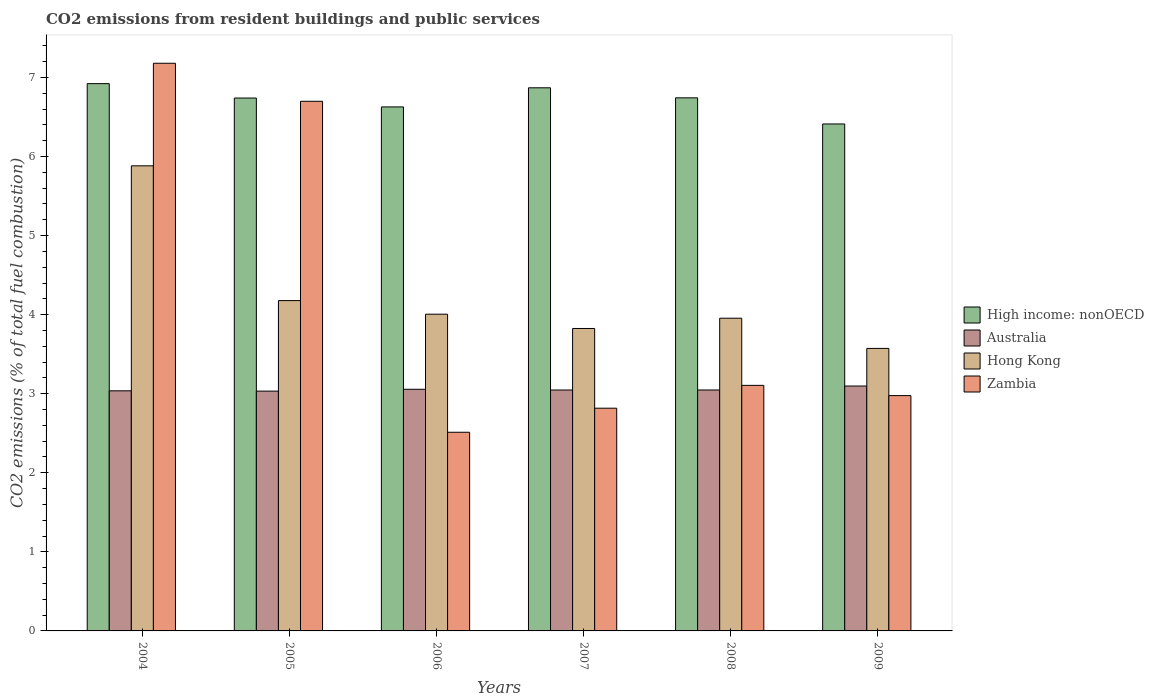How many bars are there on the 5th tick from the left?
Your answer should be compact. 4. How many bars are there on the 4th tick from the right?
Your answer should be very brief. 4. In how many cases, is the number of bars for a given year not equal to the number of legend labels?
Offer a terse response. 0. What is the total CO2 emitted in Hong Kong in 2009?
Give a very brief answer. 3.57. Across all years, what is the maximum total CO2 emitted in High income: nonOECD?
Give a very brief answer. 6.92. Across all years, what is the minimum total CO2 emitted in Hong Kong?
Offer a terse response. 3.57. What is the total total CO2 emitted in Hong Kong in the graph?
Keep it short and to the point. 25.42. What is the difference between the total CO2 emitted in Zambia in 2004 and that in 2008?
Your answer should be compact. 4.07. What is the difference between the total CO2 emitted in Australia in 2005 and the total CO2 emitted in High income: nonOECD in 2006?
Provide a short and direct response. -3.59. What is the average total CO2 emitted in High income: nonOECD per year?
Make the answer very short. 6.72. In the year 2006, what is the difference between the total CO2 emitted in Zambia and total CO2 emitted in Hong Kong?
Give a very brief answer. -1.49. What is the ratio of the total CO2 emitted in Zambia in 2007 to that in 2008?
Your answer should be compact. 0.91. Is the total CO2 emitted in High income: nonOECD in 2008 less than that in 2009?
Ensure brevity in your answer.  No. What is the difference between the highest and the second highest total CO2 emitted in Hong Kong?
Provide a short and direct response. 1.7. What is the difference between the highest and the lowest total CO2 emitted in High income: nonOECD?
Your answer should be very brief. 0.51. Is it the case that in every year, the sum of the total CO2 emitted in Zambia and total CO2 emitted in Hong Kong is greater than the sum of total CO2 emitted in High income: nonOECD and total CO2 emitted in Australia?
Offer a terse response. No. What does the 3rd bar from the left in 2005 represents?
Provide a succinct answer. Hong Kong. What does the 1st bar from the right in 2008 represents?
Provide a succinct answer. Zambia. How many bars are there?
Keep it short and to the point. 24. What is the difference between two consecutive major ticks on the Y-axis?
Your answer should be compact. 1. Are the values on the major ticks of Y-axis written in scientific E-notation?
Offer a terse response. No. Does the graph contain any zero values?
Keep it short and to the point. No. Where does the legend appear in the graph?
Offer a terse response. Center right. How many legend labels are there?
Your response must be concise. 4. How are the legend labels stacked?
Your response must be concise. Vertical. What is the title of the graph?
Provide a succinct answer. CO2 emissions from resident buildings and public services. What is the label or title of the Y-axis?
Provide a succinct answer. CO2 emissions (% of total fuel combustion). What is the CO2 emissions (% of total fuel combustion) in High income: nonOECD in 2004?
Give a very brief answer. 6.92. What is the CO2 emissions (% of total fuel combustion) in Australia in 2004?
Your answer should be very brief. 3.04. What is the CO2 emissions (% of total fuel combustion) of Hong Kong in 2004?
Your answer should be compact. 5.88. What is the CO2 emissions (% of total fuel combustion) of Zambia in 2004?
Your response must be concise. 7.18. What is the CO2 emissions (% of total fuel combustion) of High income: nonOECD in 2005?
Provide a short and direct response. 6.74. What is the CO2 emissions (% of total fuel combustion) of Australia in 2005?
Make the answer very short. 3.03. What is the CO2 emissions (% of total fuel combustion) in Hong Kong in 2005?
Your answer should be very brief. 4.18. What is the CO2 emissions (% of total fuel combustion) in Zambia in 2005?
Make the answer very short. 6.7. What is the CO2 emissions (% of total fuel combustion) of High income: nonOECD in 2006?
Give a very brief answer. 6.63. What is the CO2 emissions (% of total fuel combustion) in Australia in 2006?
Offer a very short reply. 3.06. What is the CO2 emissions (% of total fuel combustion) of Hong Kong in 2006?
Make the answer very short. 4.01. What is the CO2 emissions (% of total fuel combustion) of Zambia in 2006?
Offer a very short reply. 2.51. What is the CO2 emissions (% of total fuel combustion) of High income: nonOECD in 2007?
Provide a succinct answer. 6.87. What is the CO2 emissions (% of total fuel combustion) in Australia in 2007?
Your answer should be compact. 3.05. What is the CO2 emissions (% of total fuel combustion) in Hong Kong in 2007?
Your answer should be very brief. 3.83. What is the CO2 emissions (% of total fuel combustion) of Zambia in 2007?
Give a very brief answer. 2.82. What is the CO2 emissions (% of total fuel combustion) of High income: nonOECD in 2008?
Your answer should be compact. 6.74. What is the CO2 emissions (% of total fuel combustion) of Australia in 2008?
Your answer should be very brief. 3.05. What is the CO2 emissions (% of total fuel combustion) of Hong Kong in 2008?
Give a very brief answer. 3.96. What is the CO2 emissions (% of total fuel combustion) in Zambia in 2008?
Ensure brevity in your answer.  3.11. What is the CO2 emissions (% of total fuel combustion) of High income: nonOECD in 2009?
Make the answer very short. 6.41. What is the CO2 emissions (% of total fuel combustion) of Australia in 2009?
Keep it short and to the point. 3.1. What is the CO2 emissions (% of total fuel combustion) of Hong Kong in 2009?
Your response must be concise. 3.57. What is the CO2 emissions (% of total fuel combustion) of Zambia in 2009?
Keep it short and to the point. 2.98. Across all years, what is the maximum CO2 emissions (% of total fuel combustion) in High income: nonOECD?
Ensure brevity in your answer.  6.92. Across all years, what is the maximum CO2 emissions (% of total fuel combustion) in Australia?
Your response must be concise. 3.1. Across all years, what is the maximum CO2 emissions (% of total fuel combustion) in Hong Kong?
Keep it short and to the point. 5.88. Across all years, what is the maximum CO2 emissions (% of total fuel combustion) of Zambia?
Your answer should be compact. 7.18. Across all years, what is the minimum CO2 emissions (% of total fuel combustion) in High income: nonOECD?
Make the answer very short. 6.41. Across all years, what is the minimum CO2 emissions (% of total fuel combustion) in Australia?
Your answer should be very brief. 3.03. Across all years, what is the minimum CO2 emissions (% of total fuel combustion) of Hong Kong?
Ensure brevity in your answer.  3.57. Across all years, what is the minimum CO2 emissions (% of total fuel combustion) in Zambia?
Give a very brief answer. 2.51. What is the total CO2 emissions (% of total fuel combustion) of High income: nonOECD in the graph?
Give a very brief answer. 40.31. What is the total CO2 emissions (% of total fuel combustion) in Australia in the graph?
Keep it short and to the point. 18.32. What is the total CO2 emissions (% of total fuel combustion) in Hong Kong in the graph?
Offer a very short reply. 25.42. What is the total CO2 emissions (% of total fuel combustion) of Zambia in the graph?
Offer a terse response. 25.29. What is the difference between the CO2 emissions (% of total fuel combustion) of High income: nonOECD in 2004 and that in 2005?
Offer a very short reply. 0.18. What is the difference between the CO2 emissions (% of total fuel combustion) in Australia in 2004 and that in 2005?
Offer a terse response. 0. What is the difference between the CO2 emissions (% of total fuel combustion) of Hong Kong in 2004 and that in 2005?
Your answer should be compact. 1.7. What is the difference between the CO2 emissions (% of total fuel combustion) in Zambia in 2004 and that in 2005?
Ensure brevity in your answer.  0.48. What is the difference between the CO2 emissions (% of total fuel combustion) of High income: nonOECD in 2004 and that in 2006?
Keep it short and to the point. 0.29. What is the difference between the CO2 emissions (% of total fuel combustion) of Australia in 2004 and that in 2006?
Offer a terse response. -0.02. What is the difference between the CO2 emissions (% of total fuel combustion) in Hong Kong in 2004 and that in 2006?
Give a very brief answer. 1.88. What is the difference between the CO2 emissions (% of total fuel combustion) of Zambia in 2004 and that in 2006?
Your answer should be compact. 4.67. What is the difference between the CO2 emissions (% of total fuel combustion) of High income: nonOECD in 2004 and that in 2007?
Offer a very short reply. 0.05. What is the difference between the CO2 emissions (% of total fuel combustion) in Australia in 2004 and that in 2007?
Your answer should be very brief. -0.01. What is the difference between the CO2 emissions (% of total fuel combustion) in Hong Kong in 2004 and that in 2007?
Offer a very short reply. 2.06. What is the difference between the CO2 emissions (% of total fuel combustion) of Zambia in 2004 and that in 2007?
Provide a short and direct response. 4.36. What is the difference between the CO2 emissions (% of total fuel combustion) in High income: nonOECD in 2004 and that in 2008?
Keep it short and to the point. 0.18. What is the difference between the CO2 emissions (% of total fuel combustion) in Australia in 2004 and that in 2008?
Your answer should be very brief. -0.01. What is the difference between the CO2 emissions (% of total fuel combustion) in Hong Kong in 2004 and that in 2008?
Your answer should be compact. 1.93. What is the difference between the CO2 emissions (% of total fuel combustion) in Zambia in 2004 and that in 2008?
Keep it short and to the point. 4.07. What is the difference between the CO2 emissions (% of total fuel combustion) of High income: nonOECD in 2004 and that in 2009?
Ensure brevity in your answer.  0.51. What is the difference between the CO2 emissions (% of total fuel combustion) in Australia in 2004 and that in 2009?
Provide a succinct answer. -0.06. What is the difference between the CO2 emissions (% of total fuel combustion) of Hong Kong in 2004 and that in 2009?
Make the answer very short. 2.31. What is the difference between the CO2 emissions (% of total fuel combustion) in Zambia in 2004 and that in 2009?
Provide a short and direct response. 4.2. What is the difference between the CO2 emissions (% of total fuel combustion) in High income: nonOECD in 2005 and that in 2006?
Ensure brevity in your answer.  0.11. What is the difference between the CO2 emissions (% of total fuel combustion) in Australia in 2005 and that in 2006?
Offer a terse response. -0.02. What is the difference between the CO2 emissions (% of total fuel combustion) of Hong Kong in 2005 and that in 2006?
Keep it short and to the point. 0.17. What is the difference between the CO2 emissions (% of total fuel combustion) of Zambia in 2005 and that in 2006?
Your response must be concise. 4.19. What is the difference between the CO2 emissions (% of total fuel combustion) in High income: nonOECD in 2005 and that in 2007?
Keep it short and to the point. -0.13. What is the difference between the CO2 emissions (% of total fuel combustion) of Australia in 2005 and that in 2007?
Ensure brevity in your answer.  -0.01. What is the difference between the CO2 emissions (% of total fuel combustion) in Hong Kong in 2005 and that in 2007?
Provide a succinct answer. 0.35. What is the difference between the CO2 emissions (% of total fuel combustion) of Zambia in 2005 and that in 2007?
Keep it short and to the point. 3.88. What is the difference between the CO2 emissions (% of total fuel combustion) of High income: nonOECD in 2005 and that in 2008?
Your response must be concise. -0. What is the difference between the CO2 emissions (% of total fuel combustion) in Australia in 2005 and that in 2008?
Offer a terse response. -0.01. What is the difference between the CO2 emissions (% of total fuel combustion) in Hong Kong in 2005 and that in 2008?
Provide a succinct answer. 0.22. What is the difference between the CO2 emissions (% of total fuel combustion) of Zambia in 2005 and that in 2008?
Offer a terse response. 3.59. What is the difference between the CO2 emissions (% of total fuel combustion) of High income: nonOECD in 2005 and that in 2009?
Give a very brief answer. 0.33. What is the difference between the CO2 emissions (% of total fuel combustion) in Australia in 2005 and that in 2009?
Your response must be concise. -0.06. What is the difference between the CO2 emissions (% of total fuel combustion) in Hong Kong in 2005 and that in 2009?
Your response must be concise. 0.6. What is the difference between the CO2 emissions (% of total fuel combustion) of Zambia in 2005 and that in 2009?
Make the answer very short. 3.72. What is the difference between the CO2 emissions (% of total fuel combustion) in High income: nonOECD in 2006 and that in 2007?
Your answer should be very brief. -0.24. What is the difference between the CO2 emissions (% of total fuel combustion) in Australia in 2006 and that in 2007?
Offer a very short reply. 0.01. What is the difference between the CO2 emissions (% of total fuel combustion) in Hong Kong in 2006 and that in 2007?
Provide a succinct answer. 0.18. What is the difference between the CO2 emissions (% of total fuel combustion) in Zambia in 2006 and that in 2007?
Provide a short and direct response. -0.3. What is the difference between the CO2 emissions (% of total fuel combustion) of High income: nonOECD in 2006 and that in 2008?
Offer a terse response. -0.11. What is the difference between the CO2 emissions (% of total fuel combustion) in Australia in 2006 and that in 2008?
Keep it short and to the point. 0.01. What is the difference between the CO2 emissions (% of total fuel combustion) of Hong Kong in 2006 and that in 2008?
Your answer should be very brief. 0.05. What is the difference between the CO2 emissions (% of total fuel combustion) in Zambia in 2006 and that in 2008?
Your answer should be very brief. -0.59. What is the difference between the CO2 emissions (% of total fuel combustion) in High income: nonOECD in 2006 and that in 2009?
Your answer should be very brief. 0.22. What is the difference between the CO2 emissions (% of total fuel combustion) of Australia in 2006 and that in 2009?
Your response must be concise. -0.04. What is the difference between the CO2 emissions (% of total fuel combustion) in Hong Kong in 2006 and that in 2009?
Provide a succinct answer. 0.43. What is the difference between the CO2 emissions (% of total fuel combustion) in Zambia in 2006 and that in 2009?
Your answer should be very brief. -0.46. What is the difference between the CO2 emissions (% of total fuel combustion) of High income: nonOECD in 2007 and that in 2008?
Provide a short and direct response. 0.13. What is the difference between the CO2 emissions (% of total fuel combustion) in Australia in 2007 and that in 2008?
Provide a succinct answer. -0. What is the difference between the CO2 emissions (% of total fuel combustion) in Hong Kong in 2007 and that in 2008?
Make the answer very short. -0.13. What is the difference between the CO2 emissions (% of total fuel combustion) of Zambia in 2007 and that in 2008?
Make the answer very short. -0.29. What is the difference between the CO2 emissions (% of total fuel combustion) in High income: nonOECD in 2007 and that in 2009?
Your answer should be very brief. 0.46. What is the difference between the CO2 emissions (% of total fuel combustion) of Australia in 2007 and that in 2009?
Ensure brevity in your answer.  -0.05. What is the difference between the CO2 emissions (% of total fuel combustion) in Hong Kong in 2007 and that in 2009?
Offer a terse response. 0.25. What is the difference between the CO2 emissions (% of total fuel combustion) of Zambia in 2007 and that in 2009?
Provide a succinct answer. -0.16. What is the difference between the CO2 emissions (% of total fuel combustion) in High income: nonOECD in 2008 and that in 2009?
Provide a short and direct response. 0.33. What is the difference between the CO2 emissions (% of total fuel combustion) of Australia in 2008 and that in 2009?
Offer a terse response. -0.05. What is the difference between the CO2 emissions (% of total fuel combustion) in Hong Kong in 2008 and that in 2009?
Provide a short and direct response. 0.38. What is the difference between the CO2 emissions (% of total fuel combustion) in Zambia in 2008 and that in 2009?
Provide a short and direct response. 0.13. What is the difference between the CO2 emissions (% of total fuel combustion) in High income: nonOECD in 2004 and the CO2 emissions (% of total fuel combustion) in Australia in 2005?
Offer a very short reply. 3.89. What is the difference between the CO2 emissions (% of total fuel combustion) of High income: nonOECD in 2004 and the CO2 emissions (% of total fuel combustion) of Hong Kong in 2005?
Offer a terse response. 2.74. What is the difference between the CO2 emissions (% of total fuel combustion) in High income: nonOECD in 2004 and the CO2 emissions (% of total fuel combustion) in Zambia in 2005?
Make the answer very short. 0.22. What is the difference between the CO2 emissions (% of total fuel combustion) in Australia in 2004 and the CO2 emissions (% of total fuel combustion) in Hong Kong in 2005?
Ensure brevity in your answer.  -1.14. What is the difference between the CO2 emissions (% of total fuel combustion) in Australia in 2004 and the CO2 emissions (% of total fuel combustion) in Zambia in 2005?
Provide a succinct answer. -3.66. What is the difference between the CO2 emissions (% of total fuel combustion) in Hong Kong in 2004 and the CO2 emissions (% of total fuel combustion) in Zambia in 2005?
Keep it short and to the point. -0.82. What is the difference between the CO2 emissions (% of total fuel combustion) in High income: nonOECD in 2004 and the CO2 emissions (% of total fuel combustion) in Australia in 2006?
Ensure brevity in your answer.  3.87. What is the difference between the CO2 emissions (% of total fuel combustion) in High income: nonOECD in 2004 and the CO2 emissions (% of total fuel combustion) in Hong Kong in 2006?
Offer a terse response. 2.92. What is the difference between the CO2 emissions (% of total fuel combustion) of High income: nonOECD in 2004 and the CO2 emissions (% of total fuel combustion) of Zambia in 2006?
Offer a very short reply. 4.41. What is the difference between the CO2 emissions (% of total fuel combustion) in Australia in 2004 and the CO2 emissions (% of total fuel combustion) in Hong Kong in 2006?
Make the answer very short. -0.97. What is the difference between the CO2 emissions (% of total fuel combustion) of Australia in 2004 and the CO2 emissions (% of total fuel combustion) of Zambia in 2006?
Offer a terse response. 0.52. What is the difference between the CO2 emissions (% of total fuel combustion) in Hong Kong in 2004 and the CO2 emissions (% of total fuel combustion) in Zambia in 2006?
Keep it short and to the point. 3.37. What is the difference between the CO2 emissions (% of total fuel combustion) of High income: nonOECD in 2004 and the CO2 emissions (% of total fuel combustion) of Australia in 2007?
Make the answer very short. 3.87. What is the difference between the CO2 emissions (% of total fuel combustion) in High income: nonOECD in 2004 and the CO2 emissions (% of total fuel combustion) in Hong Kong in 2007?
Provide a succinct answer. 3.1. What is the difference between the CO2 emissions (% of total fuel combustion) of High income: nonOECD in 2004 and the CO2 emissions (% of total fuel combustion) of Zambia in 2007?
Your response must be concise. 4.11. What is the difference between the CO2 emissions (% of total fuel combustion) of Australia in 2004 and the CO2 emissions (% of total fuel combustion) of Hong Kong in 2007?
Offer a very short reply. -0.79. What is the difference between the CO2 emissions (% of total fuel combustion) in Australia in 2004 and the CO2 emissions (% of total fuel combustion) in Zambia in 2007?
Keep it short and to the point. 0.22. What is the difference between the CO2 emissions (% of total fuel combustion) in Hong Kong in 2004 and the CO2 emissions (% of total fuel combustion) in Zambia in 2007?
Make the answer very short. 3.07. What is the difference between the CO2 emissions (% of total fuel combustion) of High income: nonOECD in 2004 and the CO2 emissions (% of total fuel combustion) of Australia in 2008?
Your answer should be very brief. 3.87. What is the difference between the CO2 emissions (% of total fuel combustion) of High income: nonOECD in 2004 and the CO2 emissions (% of total fuel combustion) of Hong Kong in 2008?
Provide a short and direct response. 2.97. What is the difference between the CO2 emissions (% of total fuel combustion) of High income: nonOECD in 2004 and the CO2 emissions (% of total fuel combustion) of Zambia in 2008?
Provide a short and direct response. 3.82. What is the difference between the CO2 emissions (% of total fuel combustion) of Australia in 2004 and the CO2 emissions (% of total fuel combustion) of Hong Kong in 2008?
Your answer should be very brief. -0.92. What is the difference between the CO2 emissions (% of total fuel combustion) in Australia in 2004 and the CO2 emissions (% of total fuel combustion) in Zambia in 2008?
Offer a very short reply. -0.07. What is the difference between the CO2 emissions (% of total fuel combustion) of Hong Kong in 2004 and the CO2 emissions (% of total fuel combustion) of Zambia in 2008?
Your answer should be compact. 2.78. What is the difference between the CO2 emissions (% of total fuel combustion) in High income: nonOECD in 2004 and the CO2 emissions (% of total fuel combustion) in Australia in 2009?
Make the answer very short. 3.82. What is the difference between the CO2 emissions (% of total fuel combustion) of High income: nonOECD in 2004 and the CO2 emissions (% of total fuel combustion) of Hong Kong in 2009?
Keep it short and to the point. 3.35. What is the difference between the CO2 emissions (% of total fuel combustion) in High income: nonOECD in 2004 and the CO2 emissions (% of total fuel combustion) in Zambia in 2009?
Give a very brief answer. 3.95. What is the difference between the CO2 emissions (% of total fuel combustion) of Australia in 2004 and the CO2 emissions (% of total fuel combustion) of Hong Kong in 2009?
Provide a succinct answer. -0.54. What is the difference between the CO2 emissions (% of total fuel combustion) in Australia in 2004 and the CO2 emissions (% of total fuel combustion) in Zambia in 2009?
Provide a short and direct response. 0.06. What is the difference between the CO2 emissions (% of total fuel combustion) in Hong Kong in 2004 and the CO2 emissions (% of total fuel combustion) in Zambia in 2009?
Your response must be concise. 2.91. What is the difference between the CO2 emissions (% of total fuel combustion) of High income: nonOECD in 2005 and the CO2 emissions (% of total fuel combustion) of Australia in 2006?
Keep it short and to the point. 3.68. What is the difference between the CO2 emissions (% of total fuel combustion) of High income: nonOECD in 2005 and the CO2 emissions (% of total fuel combustion) of Hong Kong in 2006?
Your answer should be compact. 2.73. What is the difference between the CO2 emissions (% of total fuel combustion) of High income: nonOECD in 2005 and the CO2 emissions (% of total fuel combustion) of Zambia in 2006?
Your answer should be very brief. 4.23. What is the difference between the CO2 emissions (% of total fuel combustion) in Australia in 2005 and the CO2 emissions (% of total fuel combustion) in Hong Kong in 2006?
Your response must be concise. -0.97. What is the difference between the CO2 emissions (% of total fuel combustion) in Australia in 2005 and the CO2 emissions (% of total fuel combustion) in Zambia in 2006?
Keep it short and to the point. 0.52. What is the difference between the CO2 emissions (% of total fuel combustion) in Hong Kong in 2005 and the CO2 emissions (% of total fuel combustion) in Zambia in 2006?
Your answer should be very brief. 1.67. What is the difference between the CO2 emissions (% of total fuel combustion) in High income: nonOECD in 2005 and the CO2 emissions (% of total fuel combustion) in Australia in 2007?
Offer a terse response. 3.69. What is the difference between the CO2 emissions (% of total fuel combustion) of High income: nonOECD in 2005 and the CO2 emissions (% of total fuel combustion) of Hong Kong in 2007?
Give a very brief answer. 2.91. What is the difference between the CO2 emissions (% of total fuel combustion) of High income: nonOECD in 2005 and the CO2 emissions (% of total fuel combustion) of Zambia in 2007?
Your answer should be very brief. 3.92. What is the difference between the CO2 emissions (% of total fuel combustion) of Australia in 2005 and the CO2 emissions (% of total fuel combustion) of Hong Kong in 2007?
Offer a very short reply. -0.79. What is the difference between the CO2 emissions (% of total fuel combustion) of Australia in 2005 and the CO2 emissions (% of total fuel combustion) of Zambia in 2007?
Provide a succinct answer. 0.22. What is the difference between the CO2 emissions (% of total fuel combustion) of Hong Kong in 2005 and the CO2 emissions (% of total fuel combustion) of Zambia in 2007?
Your answer should be compact. 1.36. What is the difference between the CO2 emissions (% of total fuel combustion) of High income: nonOECD in 2005 and the CO2 emissions (% of total fuel combustion) of Australia in 2008?
Provide a succinct answer. 3.69. What is the difference between the CO2 emissions (% of total fuel combustion) in High income: nonOECD in 2005 and the CO2 emissions (% of total fuel combustion) in Hong Kong in 2008?
Make the answer very short. 2.78. What is the difference between the CO2 emissions (% of total fuel combustion) in High income: nonOECD in 2005 and the CO2 emissions (% of total fuel combustion) in Zambia in 2008?
Make the answer very short. 3.63. What is the difference between the CO2 emissions (% of total fuel combustion) of Australia in 2005 and the CO2 emissions (% of total fuel combustion) of Hong Kong in 2008?
Provide a short and direct response. -0.92. What is the difference between the CO2 emissions (% of total fuel combustion) of Australia in 2005 and the CO2 emissions (% of total fuel combustion) of Zambia in 2008?
Your answer should be compact. -0.07. What is the difference between the CO2 emissions (% of total fuel combustion) of Hong Kong in 2005 and the CO2 emissions (% of total fuel combustion) of Zambia in 2008?
Provide a short and direct response. 1.07. What is the difference between the CO2 emissions (% of total fuel combustion) in High income: nonOECD in 2005 and the CO2 emissions (% of total fuel combustion) in Australia in 2009?
Offer a very short reply. 3.64. What is the difference between the CO2 emissions (% of total fuel combustion) of High income: nonOECD in 2005 and the CO2 emissions (% of total fuel combustion) of Hong Kong in 2009?
Your answer should be compact. 3.17. What is the difference between the CO2 emissions (% of total fuel combustion) of High income: nonOECD in 2005 and the CO2 emissions (% of total fuel combustion) of Zambia in 2009?
Offer a terse response. 3.76. What is the difference between the CO2 emissions (% of total fuel combustion) of Australia in 2005 and the CO2 emissions (% of total fuel combustion) of Hong Kong in 2009?
Keep it short and to the point. -0.54. What is the difference between the CO2 emissions (% of total fuel combustion) in Australia in 2005 and the CO2 emissions (% of total fuel combustion) in Zambia in 2009?
Offer a terse response. 0.06. What is the difference between the CO2 emissions (% of total fuel combustion) of Hong Kong in 2005 and the CO2 emissions (% of total fuel combustion) of Zambia in 2009?
Ensure brevity in your answer.  1.2. What is the difference between the CO2 emissions (% of total fuel combustion) of High income: nonOECD in 2006 and the CO2 emissions (% of total fuel combustion) of Australia in 2007?
Provide a short and direct response. 3.58. What is the difference between the CO2 emissions (% of total fuel combustion) of High income: nonOECD in 2006 and the CO2 emissions (% of total fuel combustion) of Hong Kong in 2007?
Offer a very short reply. 2.8. What is the difference between the CO2 emissions (% of total fuel combustion) in High income: nonOECD in 2006 and the CO2 emissions (% of total fuel combustion) in Zambia in 2007?
Your response must be concise. 3.81. What is the difference between the CO2 emissions (% of total fuel combustion) in Australia in 2006 and the CO2 emissions (% of total fuel combustion) in Hong Kong in 2007?
Keep it short and to the point. -0.77. What is the difference between the CO2 emissions (% of total fuel combustion) in Australia in 2006 and the CO2 emissions (% of total fuel combustion) in Zambia in 2007?
Keep it short and to the point. 0.24. What is the difference between the CO2 emissions (% of total fuel combustion) in Hong Kong in 2006 and the CO2 emissions (% of total fuel combustion) in Zambia in 2007?
Provide a short and direct response. 1.19. What is the difference between the CO2 emissions (% of total fuel combustion) of High income: nonOECD in 2006 and the CO2 emissions (% of total fuel combustion) of Australia in 2008?
Ensure brevity in your answer.  3.58. What is the difference between the CO2 emissions (% of total fuel combustion) of High income: nonOECD in 2006 and the CO2 emissions (% of total fuel combustion) of Hong Kong in 2008?
Your response must be concise. 2.67. What is the difference between the CO2 emissions (% of total fuel combustion) of High income: nonOECD in 2006 and the CO2 emissions (% of total fuel combustion) of Zambia in 2008?
Provide a succinct answer. 3.52. What is the difference between the CO2 emissions (% of total fuel combustion) in Australia in 2006 and the CO2 emissions (% of total fuel combustion) in Hong Kong in 2008?
Make the answer very short. -0.9. What is the difference between the CO2 emissions (% of total fuel combustion) of Australia in 2006 and the CO2 emissions (% of total fuel combustion) of Zambia in 2008?
Provide a succinct answer. -0.05. What is the difference between the CO2 emissions (% of total fuel combustion) in Hong Kong in 2006 and the CO2 emissions (% of total fuel combustion) in Zambia in 2008?
Provide a succinct answer. 0.9. What is the difference between the CO2 emissions (% of total fuel combustion) of High income: nonOECD in 2006 and the CO2 emissions (% of total fuel combustion) of Australia in 2009?
Offer a terse response. 3.53. What is the difference between the CO2 emissions (% of total fuel combustion) in High income: nonOECD in 2006 and the CO2 emissions (% of total fuel combustion) in Hong Kong in 2009?
Offer a very short reply. 3.05. What is the difference between the CO2 emissions (% of total fuel combustion) of High income: nonOECD in 2006 and the CO2 emissions (% of total fuel combustion) of Zambia in 2009?
Ensure brevity in your answer.  3.65. What is the difference between the CO2 emissions (% of total fuel combustion) in Australia in 2006 and the CO2 emissions (% of total fuel combustion) in Hong Kong in 2009?
Keep it short and to the point. -0.52. What is the difference between the CO2 emissions (% of total fuel combustion) in Australia in 2006 and the CO2 emissions (% of total fuel combustion) in Zambia in 2009?
Your response must be concise. 0.08. What is the difference between the CO2 emissions (% of total fuel combustion) of Hong Kong in 2006 and the CO2 emissions (% of total fuel combustion) of Zambia in 2009?
Offer a terse response. 1.03. What is the difference between the CO2 emissions (% of total fuel combustion) of High income: nonOECD in 2007 and the CO2 emissions (% of total fuel combustion) of Australia in 2008?
Your answer should be compact. 3.82. What is the difference between the CO2 emissions (% of total fuel combustion) in High income: nonOECD in 2007 and the CO2 emissions (% of total fuel combustion) in Hong Kong in 2008?
Offer a very short reply. 2.91. What is the difference between the CO2 emissions (% of total fuel combustion) in High income: nonOECD in 2007 and the CO2 emissions (% of total fuel combustion) in Zambia in 2008?
Make the answer very short. 3.76. What is the difference between the CO2 emissions (% of total fuel combustion) of Australia in 2007 and the CO2 emissions (% of total fuel combustion) of Hong Kong in 2008?
Provide a short and direct response. -0.91. What is the difference between the CO2 emissions (% of total fuel combustion) in Australia in 2007 and the CO2 emissions (% of total fuel combustion) in Zambia in 2008?
Provide a succinct answer. -0.06. What is the difference between the CO2 emissions (% of total fuel combustion) of Hong Kong in 2007 and the CO2 emissions (% of total fuel combustion) of Zambia in 2008?
Your answer should be very brief. 0.72. What is the difference between the CO2 emissions (% of total fuel combustion) of High income: nonOECD in 2007 and the CO2 emissions (% of total fuel combustion) of Australia in 2009?
Provide a short and direct response. 3.77. What is the difference between the CO2 emissions (% of total fuel combustion) of High income: nonOECD in 2007 and the CO2 emissions (% of total fuel combustion) of Hong Kong in 2009?
Offer a very short reply. 3.3. What is the difference between the CO2 emissions (% of total fuel combustion) in High income: nonOECD in 2007 and the CO2 emissions (% of total fuel combustion) in Zambia in 2009?
Offer a very short reply. 3.89. What is the difference between the CO2 emissions (% of total fuel combustion) in Australia in 2007 and the CO2 emissions (% of total fuel combustion) in Hong Kong in 2009?
Your response must be concise. -0.53. What is the difference between the CO2 emissions (% of total fuel combustion) in Australia in 2007 and the CO2 emissions (% of total fuel combustion) in Zambia in 2009?
Make the answer very short. 0.07. What is the difference between the CO2 emissions (% of total fuel combustion) of Hong Kong in 2007 and the CO2 emissions (% of total fuel combustion) of Zambia in 2009?
Keep it short and to the point. 0.85. What is the difference between the CO2 emissions (% of total fuel combustion) of High income: nonOECD in 2008 and the CO2 emissions (% of total fuel combustion) of Australia in 2009?
Provide a short and direct response. 3.64. What is the difference between the CO2 emissions (% of total fuel combustion) in High income: nonOECD in 2008 and the CO2 emissions (% of total fuel combustion) in Hong Kong in 2009?
Offer a very short reply. 3.17. What is the difference between the CO2 emissions (% of total fuel combustion) in High income: nonOECD in 2008 and the CO2 emissions (% of total fuel combustion) in Zambia in 2009?
Your response must be concise. 3.77. What is the difference between the CO2 emissions (% of total fuel combustion) of Australia in 2008 and the CO2 emissions (% of total fuel combustion) of Hong Kong in 2009?
Give a very brief answer. -0.53. What is the difference between the CO2 emissions (% of total fuel combustion) in Australia in 2008 and the CO2 emissions (% of total fuel combustion) in Zambia in 2009?
Your answer should be very brief. 0.07. What is the difference between the CO2 emissions (% of total fuel combustion) in Hong Kong in 2008 and the CO2 emissions (% of total fuel combustion) in Zambia in 2009?
Provide a succinct answer. 0.98. What is the average CO2 emissions (% of total fuel combustion) in High income: nonOECD per year?
Offer a very short reply. 6.72. What is the average CO2 emissions (% of total fuel combustion) of Australia per year?
Provide a short and direct response. 3.05. What is the average CO2 emissions (% of total fuel combustion) in Hong Kong per year?
Ensure brevity in your answer.  4.24. What is the average CO2 emissions (% of total fuel combustion) of Zambia per year?
Provide a succinct answer. 4.21. In the year 2004, what is the difference between the CO2 emissions (% of total fuel combustion) in High income: nonOECD and CO2 emissions (% of total fuel combustion) in Australia?
Provide a short and direct response. 3.89. In the year 2004, what is the difference between the CO2 emissions (% of total fuel combustion) of High income: nonOECD and CO2 emissions (% of total fuel combustion) of Hong Kong?
Keep it short and to the point. 1.04. In the year 2004, what is the difference between the CO2 emissions (% of total fuel combustion) in High income: nonOECD and CO2 emissions (% of total fuel combustion) in Zambia?
Ensure brevity in your answer.  -0.26. In the year 2004, what is the difference between the CO2 emissions (% of total fuel combustion) in Australia and CO2 emissions (% of total fuel combustion) in Hong Kong?
Give a very brief answer. -2.85. In the year 2004, what is the difference between the CO2 emissions (% of total fuel combustion) in Australia and CO2 emissions (% of total fuel combustion) in Zambia?
Your answer should be very brief. -4.14. In the year 2004, what is the difference between the CO2 emissions (% of total fuel combustion) in Hong Kong and CO2 emissions (% of total fuel combustion) in Zambia?
Make the answer very short. -1.3. In the year 2005, what is the difference between the CO2 emissions (% of total fuel combustion) in High income: nonOECD and CO2 emissions (% of total fuel combustion) in Australia?
Provide a succinct answer. 3.71. In the year 2005, what is the difference between the CO2 emissions (% of total fuel combustion) of High income: nonOECD and CO2 emissions (% of total fuel combustion) of Hong Kong?
Make the answer very short. 2.56. In the year 2005, what is the difference between the CO2 emissions (% of total fuel combustion) of High income: nonOECD and CO2 emissions (% of total fuel combustion) of Zambia?
Offer a very short reply. 0.04. In the year 2005, what is the difference between the CO2 emissions (% of total fuel combustion) in Australia and CO2 emissions (% of total fuel combustion) in Hong Kong?
Your answer should be very brief. -1.14. In the year 2005, what is the difference between the CO2 emissions (% of total fuel combustion) of Australia and CO2 emissions (% of total fuel combustion) of Zambia?
Provide a short and direct response. -3.67. In the year 2005, what is the difference between the CO2 emissions (% of total fuel combustion) in Hong Kong and CO2 emissions (% of total fuel combustion) in Zambia?
Provide a succinct answer. -2.52. In the year 2006, what is the difference between the CO2 emissions (% of total fuel combustion) in High income: nonOECD and CO2 emissions (% of total fuel combustion) in Australia?
Keep it short and to the point. 3.57. In the year 2006, what is the difference between the CO2 emissions (% of total fuel combustion) of High income: nonOECD and CO2 emissions (% of total fuel combustion) of Hong Kong?
Offer a very short reply. 2.62. In the year 2006, what is the difference between the CO2 emissions (% of total fuel combustion) of High income: nonOECD and CO2 emissions (% of total fuel combustion) of Zambia?
Keep it short and to the point. 4.11. In the year 2006, what is the difference between the CO2 emissions (% of total fuel combustion) in Australia and CO2 emissions (% of total fuel combustion) in Hong Kong?
Provide a short and direct response. -0.95. In the year 2006, what is the difference between the CO2 emissions (% of total fuel combustion) of Australia and CO2 emissions (% of total fuel combustion) of Zambia?
Keep it short and to the point. 0.54. In the year 2006, what is the difference between the CO2 emissions (% of total fuel combustion) in Hong Kong and CO2 emissions (% of total fuel combustion) in Zambia?
Ensure brevity in your answer.  1.49. In the year 2007, what is the difference between the CO2 emissions (% of total fuel combustion) of High income: nonOECD and CO2 emissions (% of total fuel combustion) of Australia?
Ensure brevity in your answer.  3.82. In the year 2007, what is the difference between the CO2 emissions (% of total fuel combustion) in High income: nonOECD and CO2 emissions (% of total fuel combustion) in Hong Kong?
Your response must be concise. 3.04. In the year 2007, what is the difference between the CO2 emissions (% of total fuel combustion) in High income: nonOECD and CO2 emissions (% of total fuel combustion) in Zambia?
Make the answer very short. 4.05. In the year 2007, what is the difference between the CO2 emissions (% of total fuel combustion) in Australia and CO2 emissions (% of total fuel combustion) in Hong Kong?
Ensure brevity in your answer.  -0.78. In the year 2007, what is the difference between the CO2 emissions (% of total fuel combustion) in Australia and CO2 emissions (% of total fuel combustion) in Zambia?
Your answer should be very brief. 0.23. In the year 2007, what is the difference between the CO2 emissions (% of total fuel combustion) in Hong Kong and CO2 emissions (% of total fuel combustion) in Zambia?
Offer a terse response. 1.01. In the year 2008, what is the difference between the CO2 emissions (% of total fuel combustion) of High income: nonOECD and CO2 emissions (% of total fuel combustion) of Australia?
Give a very brief answer. 3.69. In the year 2008, what is the difference between the CO2 emissions (% of total fuel combustion) of High income: nonOECD and CO2 emissions (% of total fuel combustion) of Hong Kong?
Offer a very short reply. 2.79. In the year 2008, what is the difference between the CO2 emissions (% of total fuel combustion) in High income: nonOECD and CO2 emissions (% of total fuel combustion) in Zambia?
Your response must be concise. 3.64. In the year 2008, what is the difference between the CO2 emissions (% of total fuel combustion) of Australia and CO2 emissions (% of total fuel combustion) of Hong Kong?
Keep it short and to the point. -0.91. In the year 2008, what is the difference between the CO2 emissions (% of total fuel combustion) of Australia and CO2 emissions (% of total fuel combustion) of Zambia?
Ensure brevity in your answer.  -0.06. In the year 2008, what is the difference between the CO2 emissions (% of total fuel combustion) in Hong Kong and CO2 emissions (% of total fuel combustion) in Zambia?
Give a very brief answer. 0.85. In the year 2009, what is the difference between the CO2 emissions (% of total fuel combustion) in High income: nonOECD and CO2 emissions (% of total fuel combustion) in Australia?
Your answer should be very brief. 3.31. In the year 2009, what is the difference between the CO2 emissions (% of total fuel combustion) in High income: nonOECD and CO2 emissions (% of total fuel combustion) in Hong Kong?
Offer a terse response. 2.84. In the year 2009, what is the difference between the CO2 emissions (% of total fuel combustion) in High income: nonOECD and CO2 emissions (% of total fuel combustion) in Zambia?
Your answer should be compact. 3.44. In the year 2009, what is the difference between the CO2 emissions (% of total fuel combustion) in Australia and CO2 emissions (% of total fuel combustion) in Hong Kong?
Your answer should be very brief. -0.48. In the year 2009, what is the difference between the CO2 emissions (% of total fuel combustion) in Australia and CO2 emissions (% of total fuel combustion) in Zambia?
Make the answer very short. 0.12. In the year 2009, what is the difference between the CO2 emissions (% of total fuel combustion) in Hong Kong and CO2 emissions (% of total fuel combustion) in Zambia?
Provide a succinct answer. 0.6. What is the ratio of the CO2 emissions (% of total fuel combustion) of Hong Kong in 2004 to that in 2005?
Give a very brief answer. 1.41. What is the ratio of the CO2 emissions (% of total fuel combustion) of Zambia in 2004 to that in 2005?
Provide a succinct answer. 1.07. What is the ratio of the CO2 emissions (% of total fuel combustion) in High income: nonOECD in 2004 to that in 2006?
Make the answer very short. 1.04. What is the ratio of the CO2 emissions (% of total fuel combustion) in Hong Kong in 2004 to that in 2006?
Provide a succinct answer. 1.47. What is the ratio of the CO2 emissions (% of total fuel combustion) of Zambia in 2004 to that in 2006?
Provide a short and direct response. 2.86. What is the ratio of the CO2 emissions (% of total fuel combustion) of High income: nonOECD in 2004 to that in 2007?
Your answer should be very brief. 1.01. What is the ratio of the CO2 emissions (% of total fuel combustion) of Australia in 2004 to that in 2007?
Make the answer very short. 1. What is the ratio of the CO2 emissions (% of total fuel combustion) of Hong Kong in 2004 to that in 2007?
Keep it short and to the point. 1.54. What is the ratio of the CO2 emissions (% of total fuel combustion) of Zambia in 2004 to that in 2007?
Keep it short and to the point. 2.55. What is the ratio of the CO2 emissions (% of total fuel combustion) of High income: nonOECD in 2004 to that in 2008?
Give a very brief answer. 1.03. What is the ratio of the CO2 emissions (% of total fuel combustion) in Hong Kong in 2004 to that in 2008?
Your answer should be very brief. 1.49. What is the ratio of the CO2 emissions (% of total fuel combustion) of Zambia in 2004 to that in 2008?
Provide a succinct answer. 2.31. What is the ratio of the CO2 emissions (% of total fuel combustion) in High income: nonOECD in 2004 to that in 2009?
Your response must be concise. 1.08. What is the ratio of the CO2 emissions (% of total fuel combustion) of Australia in 2004 to that in 2009?
Give a very brief answer. 0.98. What is the ratio of the CO2 emissions (% of total fuel combustion) in Hong Kong in 2004 to that in 2009?
Your response must be concise. 1.65. What is the ratio of the CO2 emissions (% of total fuel combustion) in Zambia in 2004 to that in 2009?
Your response must be concise. 2.41. What is the ratio of the CO2 emissions (% of total fuel combustion) of High income: nonOECD in 2005 to that in 2006?
Provide a short and direct response. 1.02. What is the ratio of the CO2 emissions (% of total fuel combustion) of Australia in 2005 to that in 2006?
Your answer should be compact. 0.99. What is the ratio of the CO2 emissions (% of total fuel combustion) in Hong Kong in 2005 to that in 2006?
Ensure brevity in your answer.  1.04. What is the ratio of the CO2 emissions (% of total fuel combustion) of Zambia in 2005 to that in 2006?
Your response must be concise. 2.67. What is the ratio of the CO2 emissions (% of total fuel combustion) in High income: nonOECD in 2005 to that in 2007?
Your answer should be very brief. 0.98. What is the ratio of the CO2 emissions (% of total fuel combustion) of Hong Kong in 2005 to that in 2007?
Make the answer very short. 1.09. What is the ratio of the CO2 emissions (% of total fuel combustion) of Zambia in 2005 to that in 2007?
Your response must be concise. 2.38. What is the ratio of the CO2 emissions (% of total fuel combustion) of High income: nonOECD in 2005 to that in 2008?
Make the answer very short. 1. What is the ratio of the CO2 emissions (% of total fuel combustion) of Hong Kong in 2005 to that in 2008?
Provide a succinct answer. 1.06. What is the ratio of the CO2 emissions (% of total fuel combustion) of Zambia in 2005 to that in 2008?
Provide a succinct answer. 2.16. What is the ratio of the CO2 emissions (% of total fuel combustion) in High income: nonOECD in 2005 to that in 2009?
Provide a short and direct response. 1.05. What is the ratio of the CO2 emissions (% of total fuel combustion) in Australia in 2005 to that in 2009?
Your answer should be compact. 0.98. What is the ratio of the CO2 emissions (% of total fuel combustion) in Hong Kong in 2005 to that in 2009?
Provide a succinct answer. 1.17. What is the ratio of the CO2 emissions (% of total fuel combustion) in Zambia in 2005 to that in 2009?
Provide a succinct answer. 2.25. What is the ratio of the CO2 emissions (% of total fuel combustion) in High income: nonOECD in 2006 to that in 2007?
Offer a terse response. 0.96. What is the ratio of the CO2 emissions (% of total fuel combustion) of Australia in 2006 to that in 2007?
Offer a very short reply. 1. What is the ratio of the CO2 emissions (% of total fuel combustion) in Hong Kong in 2006 to that in 2007?
Keep it short and to the point. 1.05. What is the ratio of the CO2 emissions (% of total fuel combustion) of Zambia in 2006 to that in 2007?
Ensure brevity in your answer.  0.89. What is the ratio of the CO2 emissions (% of total fuel combustion) in High income: nonOECD in 2006 to that in 2008?
Provide a succinct answer. 0.98. What is the ratio of the CO2 emissions (% of total fuel combustion) in Hong Kong in 2006 to that in 2008?
Your answer should be very brief. 1.01. What is the ratio of the CO2 emissions (% of total fuel combustion) in Zambia in 2006 to that in 2008?
Provide a succinct answer. 0.81. What is the ratio of the CO2 emissions (% of total fuel combustion) of High income: nonOECD in 2006 to that in 2009?
Your answer should be very brief. 1.03. What is the ratio of the CO2 emissions (% of total fuel combustion) in Hong Kong in 2006 to that in 2009?
Ensure brevity in your answer.  1.12. What is the ratio of the CO2 emissions (% of total fuel combustion) of Zambia in 2006 to that in 2009?
Your response must be concise. 0.84. What is the ratio of the CO2 emissions (% of total fuel combustion) in High income: nonOECD in 2007 to that in 2008?
Your response must be concise. 1.02. What is the ratio of the CO2 emissions (% of total fuel combustion) in Australia in 2007 to that in 2008?
Offer a terse response. 1. What is the ratio of the CO2 emissions (% of total fuel combustion) of Hong Kong in 2007 to that in 2008?
Your response must be concise. 0.97. What is the ratio of the CO2 emissions (% of total fuel combustion) in Zambia in 2007 to that in 2008?
Your answer should be very brief. 0.91. What is the ratio of the CO2 emissions (% of total fuel combustion) in High income: nonOECD in 2007 to that in 2009?
Keep it short and to the point. 1.07. What is the ratio of the CO2 emissions (% of total fuel combustion) in Australia in 2007 to that in 2009?
Ensure brevity in your answer.  0.98. What is the ratio of the CO2 emissions (% of total fuel combustion) in Hong Kong in 2007 to that in 2009?
Your answer should be very brief. 1.07. What is the ratio of the CO2 emissions (% of total fuel combustion) of Zambia in 2007 to that in 2009?
Give a very brief answer. 0.95. What is the ratio of the CO2 emissions (% of total fuel combustion) of High income: nonOECD in 2008 to that in 2009?
Your response must be concise. 1.05. What is the ratio of the CO2 emissions (% of total fuel combustion) of Australia in 2008 to that in 2009?
Provide a succinct answer. 0.98. What is the ratio of the CO2 emissions (% of total fuel combustion) of Hong Kong in 2008 to that in 2009?
Provide a succinct answer. 1.11. What is the ratio of the CO2 emissions (% of total fuel combustion) of Zambia in 2008 to that in 2009?
Ensure brevity in your answer.  1.04. What is the difference between the highest and the second highest CO2 emissions (% of total fuel combustion) of High income: nonOECD?
Your response must be concise. 0.05. What is the difference between the highest and the second highest CO2 emissions (% of total fuel combustion) of Australia?
Ensure brevity in your answer.  0.04. What is the difference between the highest and the second highest CO2 emissions (% of total fuel combustion) of Hong Kong?
Make the answer very short. 1.7. What is the difference between the highest and the second highest CO2 emissions (% of total fuel combustion) in Zambia?
Give a very brief answer. 0.48. What is the difference between the highest and the lowest CO2 emissions (% of total fuel combustion) of High income: nonOECD?
Provide a succinct answer. 0.51. What is the difference between the highest and the lowest CO2 emissions (% of total fuel combustion) of Australia?
Your response must be concise. 0.06. What is the difference between the highest and the lowest CO2 emissions (% of total fuel combustion) of Hong Kong?
Give a very brief answer. 2.31. What is the difference between the highest and the lowest CO2 emissions (% of total fuel combustion) in Zambia?
Keep it short and to the point. 4.67. 